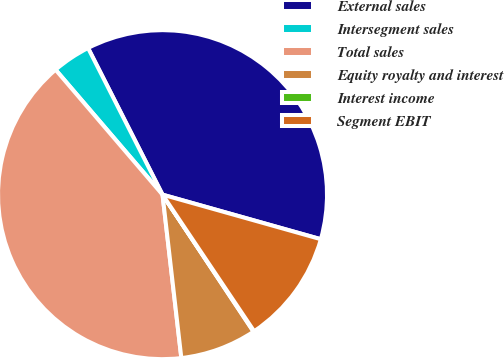<chart> <loc_0><loc_0><loc_500><loc_500><pie_chart><fcel>External sales<fcel>Intersegment sales<fcel>Total sales<fcel>Equity royalty and interest<fcel>Interest income<fcel>Segment EBIT<nl><fcel>36.85%<fcel>3.79%<fcel>40.56%<fcel>7.51%<fcel>0.07%<fcel>11.23%<nl></chart> 